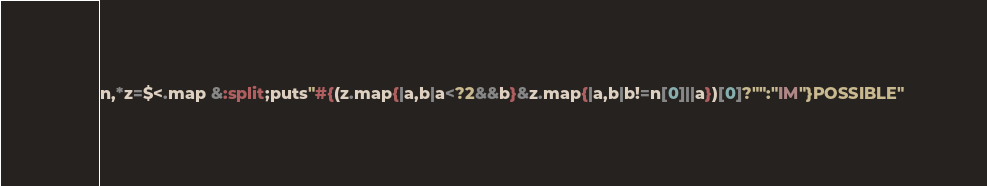<code> <loc_0><loc_0><loc_500><loc_500><_Ruby_>n,*z=$<.map &:split;puts"#{(z.map{|a,b|a<?2&&b}&z.map{|a,b|b!=n[0]||a})[0]?"":"IM"}POSSIBLE"</code> 